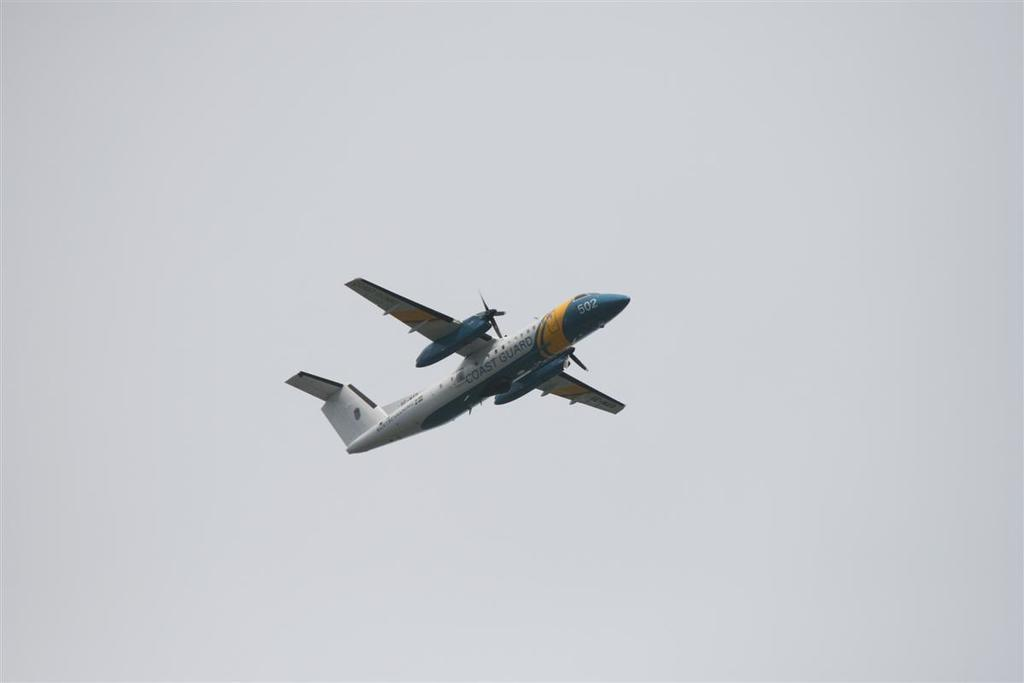What is the main subject of the image? The main subject of the image is an airplane. What is the airplane doing in the image? The airplane is flying in the air. What can be seen in the background of the image? The sky is visible in the background of the image. How many pizzas are being served on the airplane in the image? There are no pizzas visible in the image; it only features an airplane flying in the sky. 